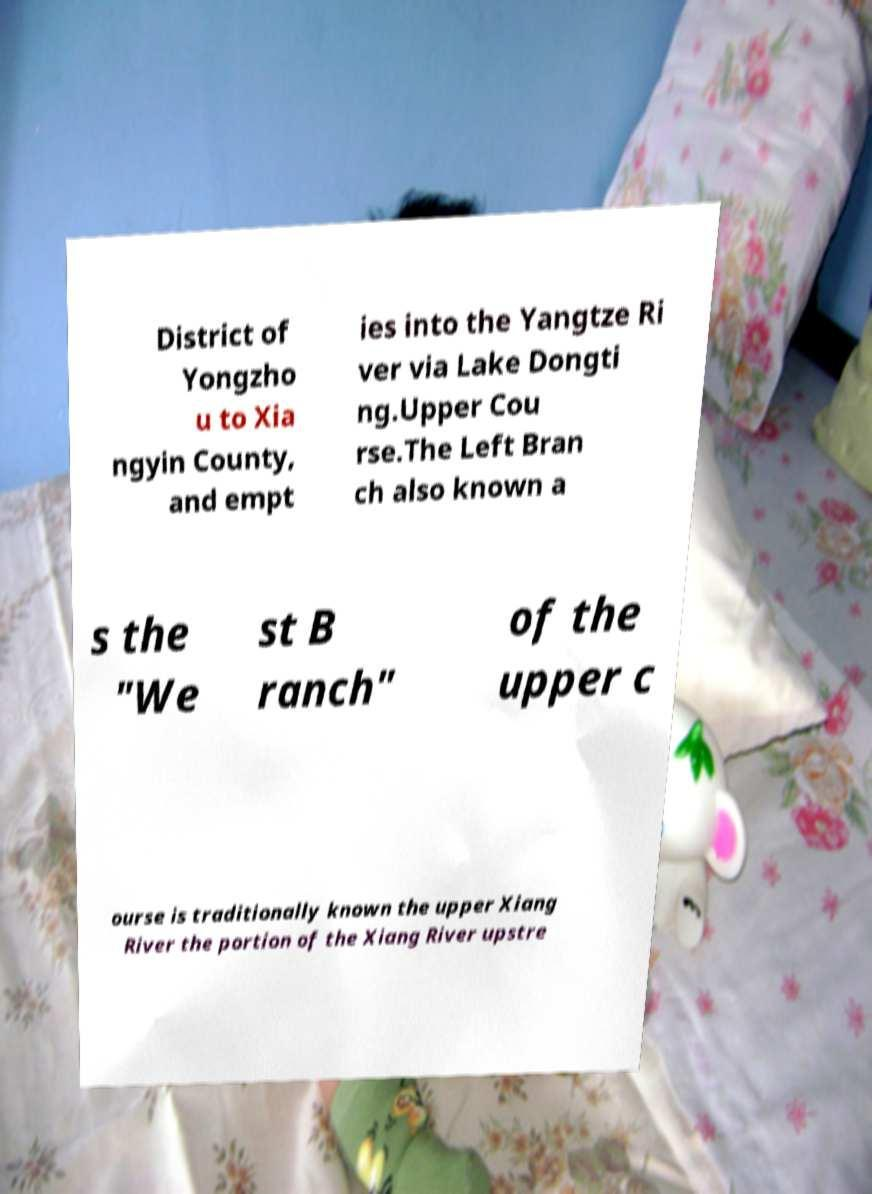Could you assist in decoding the text presented in this image and type it out clearly? District of Yongzho u to Xia ngyin County, and empt ies into the Yangtze Ri ver via Lake Dongti ng.Upper Cou rse.The Left Bran ch also known a s the "We st B ranch" of the upper c ourse is traditionally known the upper Xiang River the portion of the Xiang River upstre 